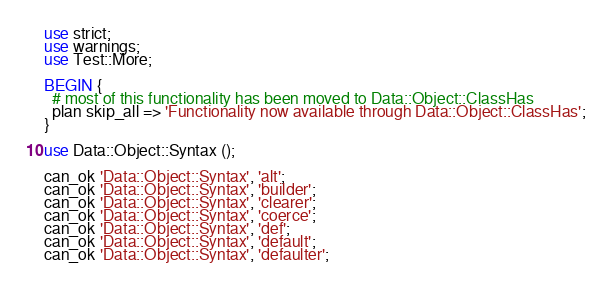<code> <loc_0><loc_0><loc_500><loc_500><_Perl_>use strict;
use warnings;
use Test::More;

BEGIN {
  # most of this functionality has been moved to Data::Object::ClassHas
  plan skip_all => 'Functionality now available through Data::Object::ClassHas';
}

use Data::Object::Syntax ();

can_ok 'Data::Object::Syntax', 'alt';
can_ok 'Data::Object::Syntax', 'builder';
can_ok 'Data::Object::Syntax', 'clearer';
can_ok 'Data::Object::Syntax', 'coerce';
can_ok 'Data::Object::Syntax', 'def';
can_ok 'Data::Object::Syntax', 'default';
can_ok 'Data::Object::Syntax', 'defaulter';</code> 